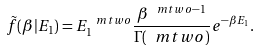<formula> <loc_0><loc_0><loc_500><loc_500>\tilde { f } ( \beta | E _ { 1 } ) = E _ { 1 } ^ { \ m t w o } \frac { \beta ^ { \ m t w o - 1 } } { \Gamma ( \ m t w o ) } e ^ { - \beta E _ { 1 } } .</formula> 